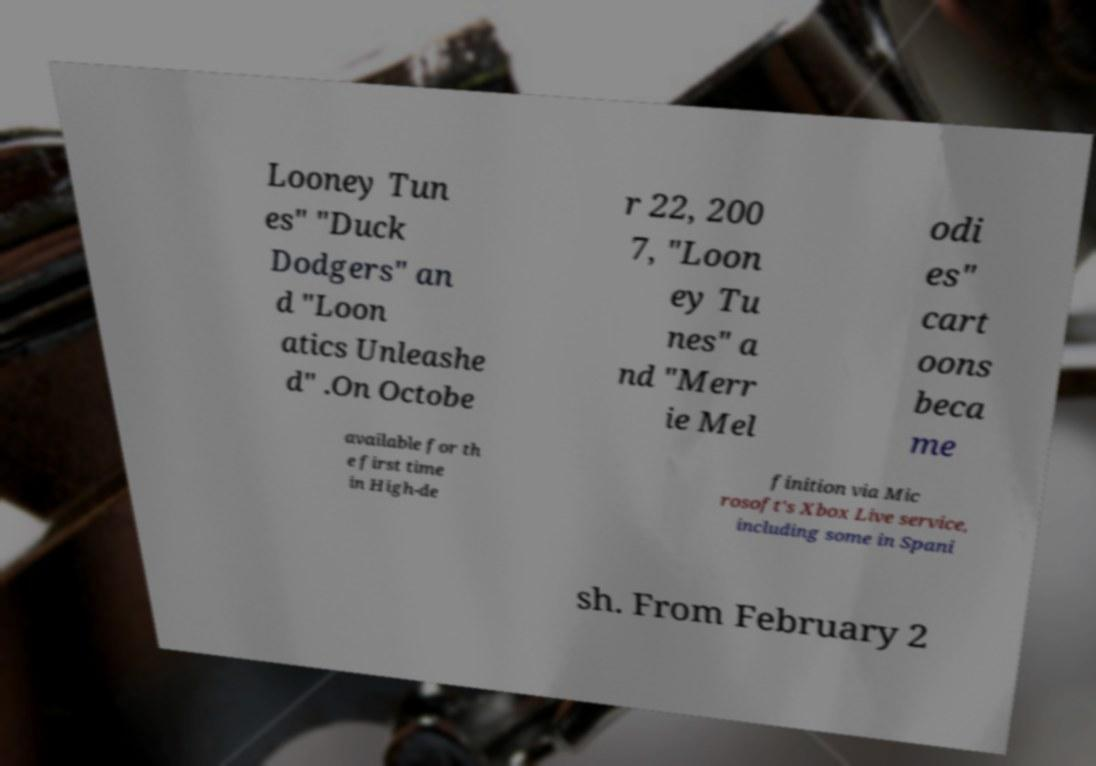Can you accurately transcribe the text from the provided image for me? Looney Tun es" "Duck Dodgers" an d "Loon atics Unleashe d" .On Octobe r 22, 200 7, "Loon ey Tu nes" a nd "Merr ie Mel odi es" cart oons beca me available for th e first time in High-de finition via Mic rosoft's Xbox Live service, including some in Spani sh. From February 2 